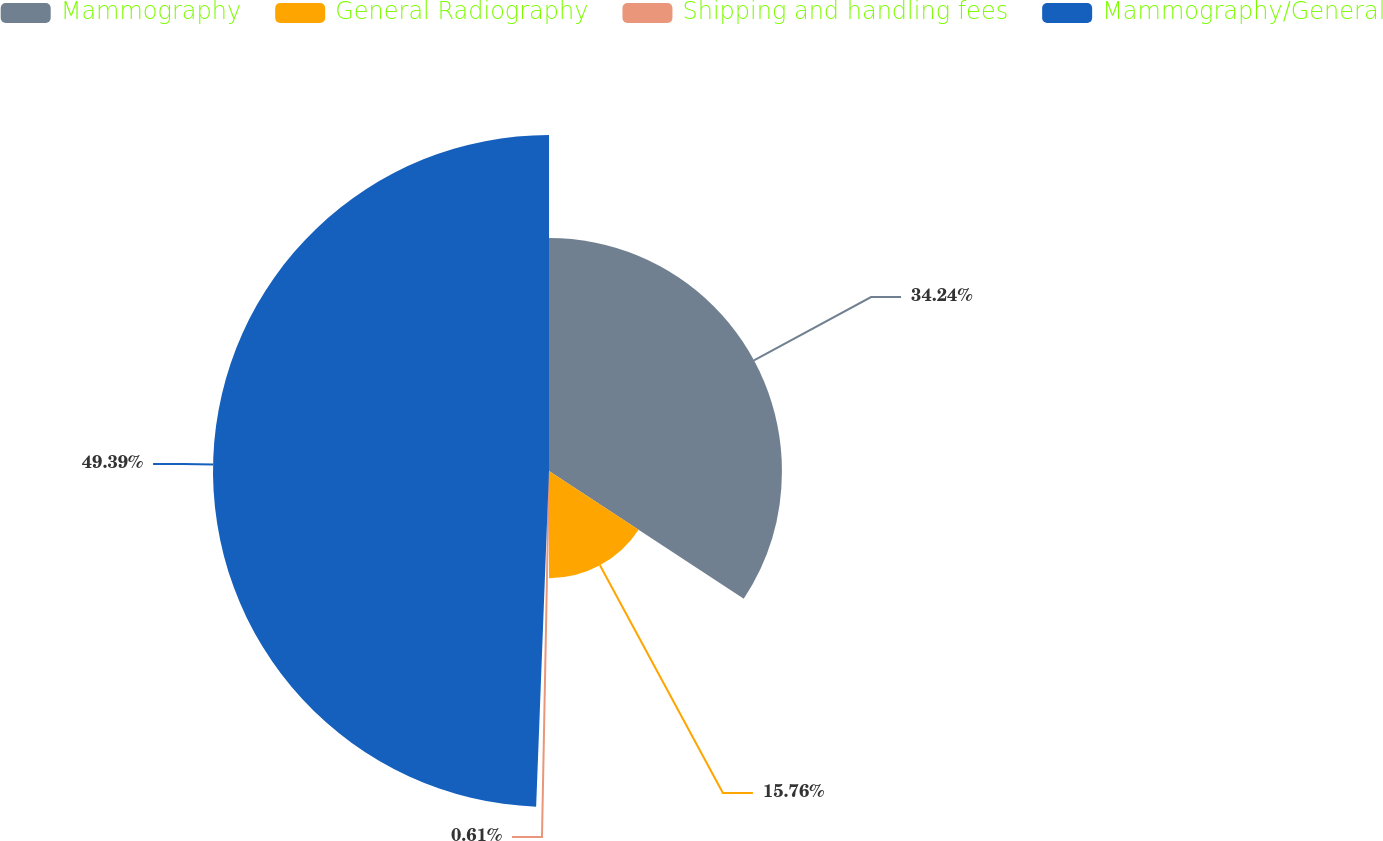Convert chart. <chart><loc_0><loc_0><loc_500><loc_500><pie_chart><fcel>Mammography<fcel>General Radiography<fcel>Shipping and handling fees<fcel>Mammography/General<nl><fcel>34.24%<fcel>15.76%<fcel>0.61%<fcel>49.39%<nl></chart> 